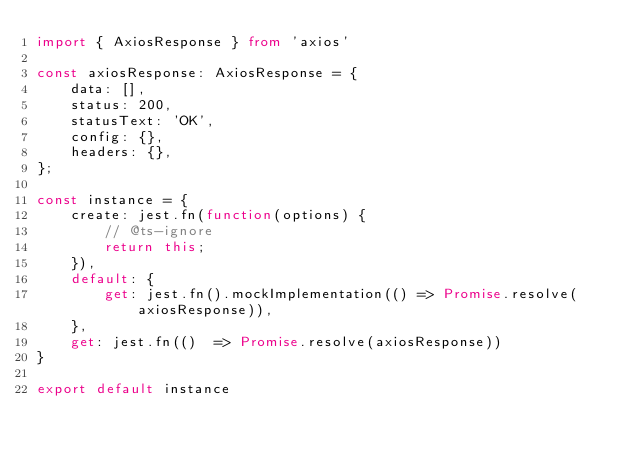<code> <loc_0><loc_0><loc_500><loc_500><_TypeScript_>import { AxiosResponse } from 'axios'

const axiosResponse: AxiosResponse = {
    data: [],
    status: 200,
    statusText: 'OK',
    config: {},
    headers: {},
};

const instance = {
    create: jest.fn(function(options) {
        // @ts-ignore
        return this;
    }),
    default: {
        get: jest.fn().mockImplementation(() => Promise.resolve(axiosResponse)),
    },
    get: jest.fn(()  => Promise.resolve(axiosResponse))
}

export default instance</code> 